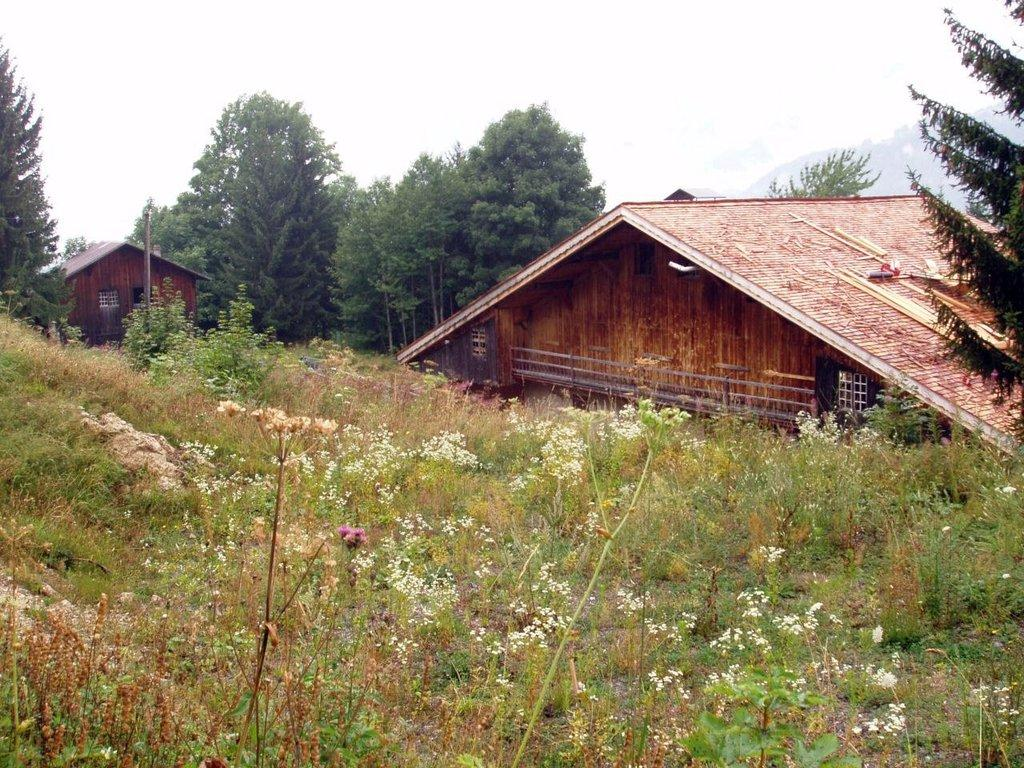What colors are the flowers in the image? The flowers in the image are white and pink. Where are the flowers located? The flowers are on plants. What can be seen in the background of the image? There are wooden houses, many trees, and the sky visible in the background of the image. Can you see a map in the image? There is no map present in the image. 